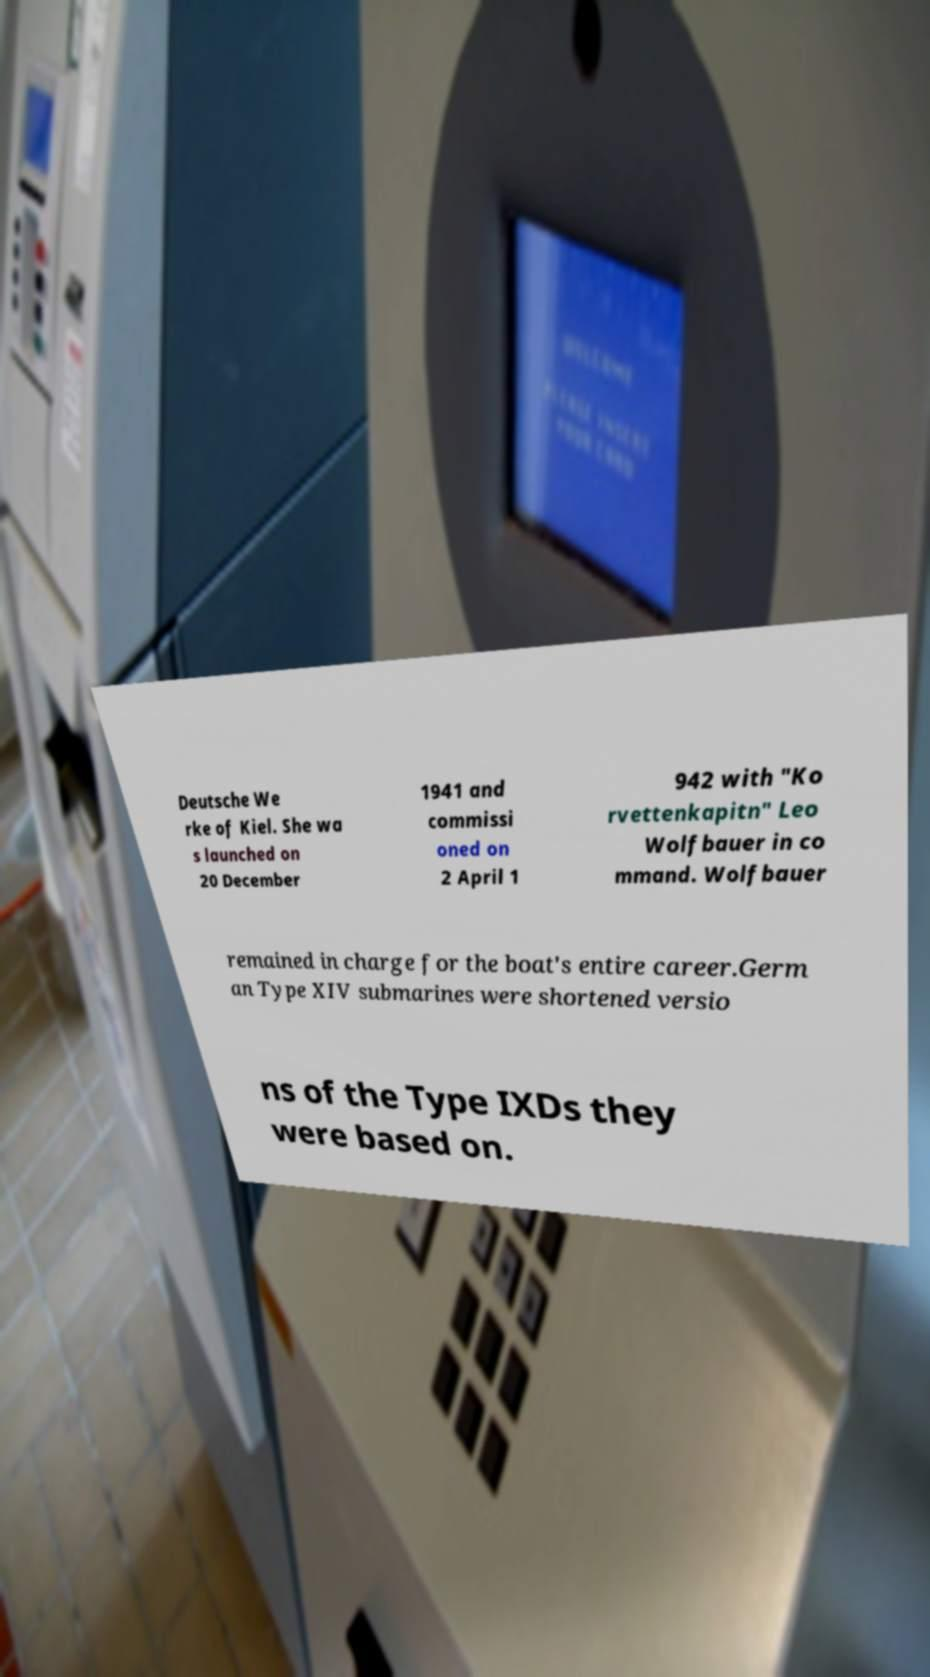For documentation purposes, I need the text within this image transcribed. Could you provide that? Deutsche We rke of Kiel. She wa s launched on 20 December 1941 and commissi oned on 2 April 1 942 with "Ko rvettenkapitn" Leo Wolfbauer in co mmand. Wolfbauer remained in charge for the boat's entire career.Germ an Type XIV submarines were shortened versio ns of the Type IXDs they were based on. 